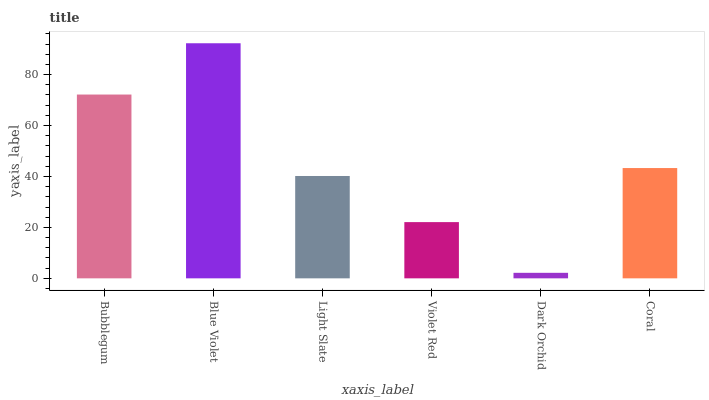Is Dark Orchid the minimum?
Answer yes or no. Yes. Is Blue Violet the maximum?
Answer yes or no. Yes. Is Light Slate the minimum?
Answer yes or no. No. Is Light Slate the maximum?
Answer yes or no. No. Is Blue Violet greater than Light Slate?
Answer yes or no. Yes. Is Light Slate less than Blue Violet?
Answer yes or no. Yes. Is Light Slate greater than Blue Violet?
Answer yes or no. No. Is Blue Violet less than Light Slate?
Answer yes or no. No. Is Coral the high median?
Answer yes or no. Yes. Is Light Slate the low median?
Answer yes or no. Yes. Is Dark Orchid the high median?
Answer yes or no. No. Is Coral the low median?
Answer yes or no. No. 